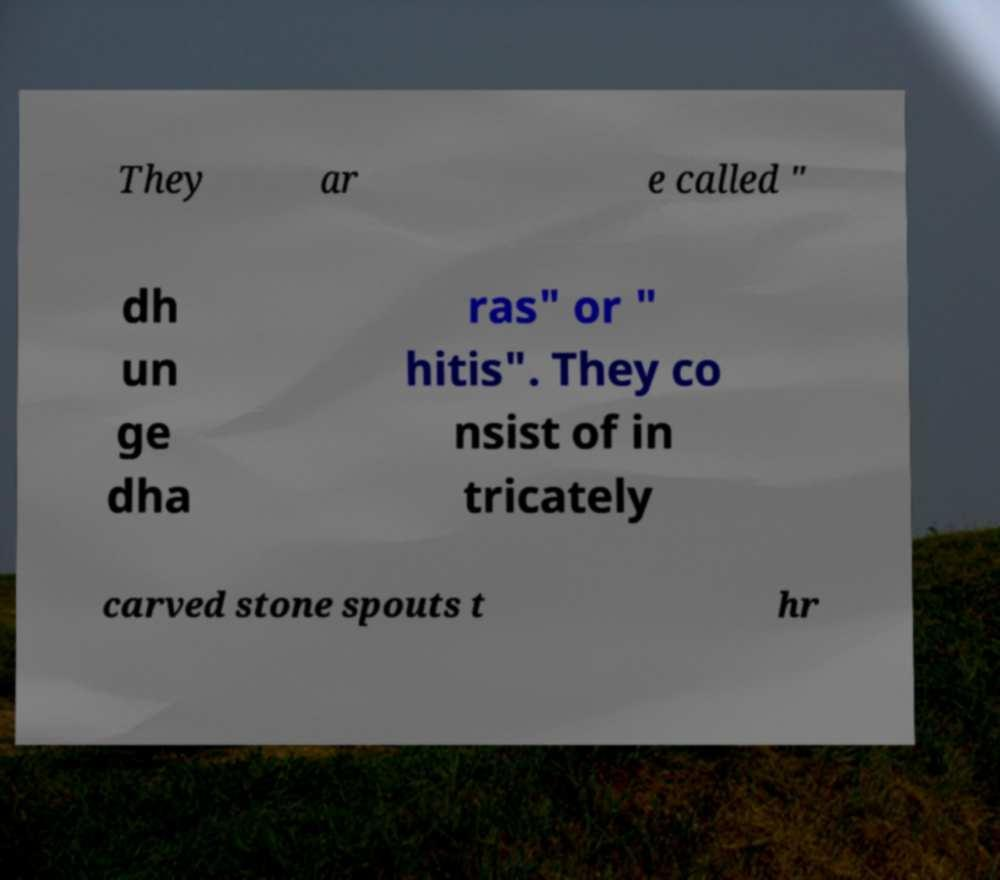Please identify and transcribe the text found in this image. They ar e called " dh un ge dha ras" or " hitis". They co nsist of in tricately carved stone spouts t hr 